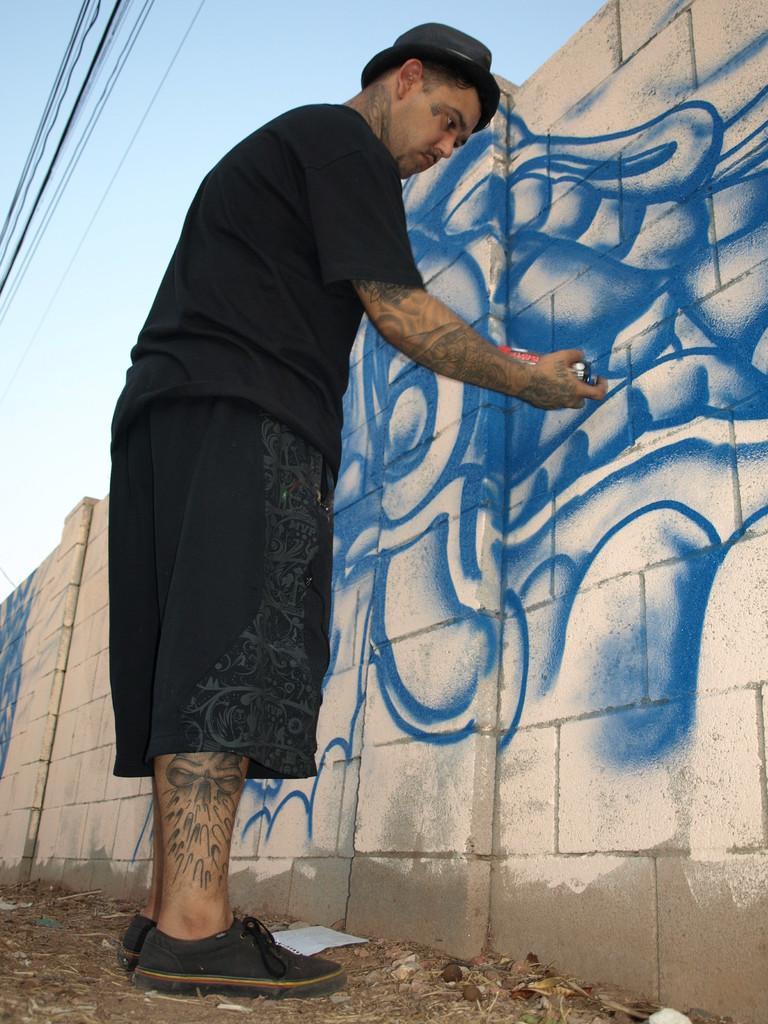Could you give a brief overview of what you see in this image? In this image we can see a person standing and holding an object and painting to the wall, at the top we can see wires and sky. 